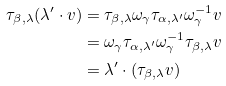Convert formula to latex. <formula><loc_0><loc_0><loc_500><loc_500>\tau _ { \beta , \lambda } ( \lambda ^ { \prime } \cdot v ) & = \tau _ { \beta , \lambda } \omega _ { \gamma } \tau _ { \alpha , \lambda ^ { \prime } } \omega _ { \gamma } ^ { - 1 } v \\ & = \omega _ { \gamma } \tau _ { \alpha , \lambda ^ { \prime } } \omega _ { \gamma } ^ { - 1 } \tau _ { \beta , \lambda } v \\ & = \lambda ^ { \prime } \cdot ( \tau _ { \beta , \lambda } v )</formula> 